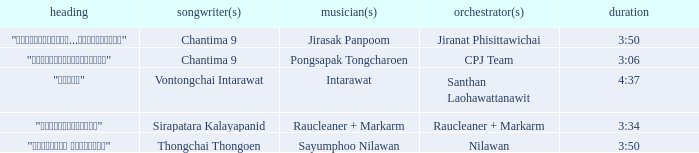Write the full table. {'header': ['heading', 'songwriter(s)', 'musician(s)', 'orchestrator(s)', 'duration'], 'rows': [['"เรายังรักกัน...ไม่ใช่เหรอ"', 'Chantima 9', 'Jirasak Panpoom', 'Jiranat Phisittawichai', '3:50'], ['"นางฟ้าตาชั้นเดียว"', 'Chantima 9', 'Pongsapak Tongcharoen', 'CPJ Team', '3:06'], ['"ขอโทษ"', 'Vontongchai Intarawat', 'Intarawat', 'Santhan Laohawattanawit', '4:37'], ['"แค่อยากให้รู้"', 'Sirapatara Kalayapanid', 'Raucleaner + Markarm', 'Raucleaner + Markarm', '3:34'], ['"เลือกลืม เลือกจำ"', 'Thongchai Thongoen', 'Sayumphoo Nilawan', 'Nilawan', '3:50']]} Who was the arranger of "ขอโทษ"? Santhan Laohawattanawit. 